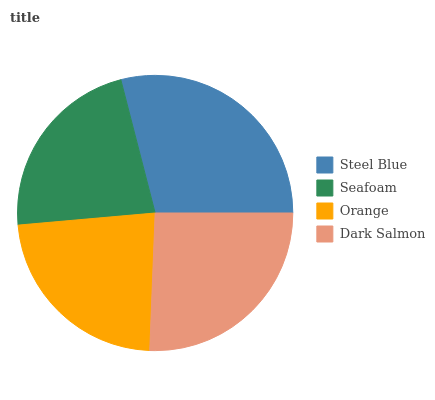Is Seafoam the minimum?
Answer yes or no. Yes. Is Steel Blue the maximum?
Answer yes or no. Yes. Is Orange the minimum?
Answer yes or no. No. Is Orange the maximum?
Answer yes or no. No. Is Orange greater than Seafoam?
Answer yes or no. Yes. Is Seafoam less than Orange?
Answer yes or no. Yes. Is Seafoam greater than Orange?
Answer yes or no. No. Is Orange less than Seafoam?
Answer yes or no. No. Is Dark Salmon the high median?
Answer yes or no. Yes. Is Orange the low median?
Answer yes or no. Yes. Is Steel Blue the high median?
Answer yes or no. No. Is Seafoam the low median?
Answer yes or no. No. 